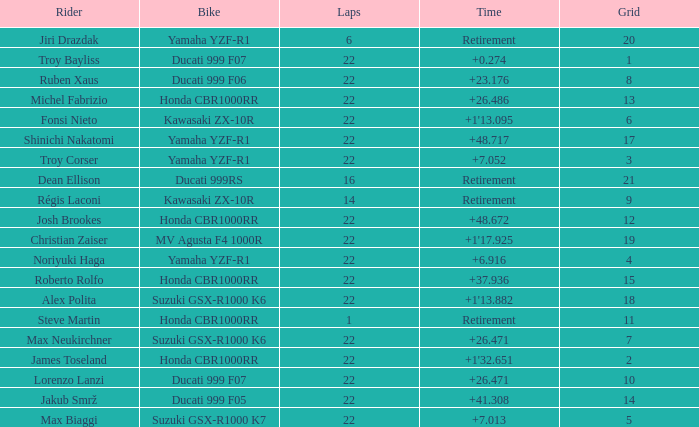Which bike did Jiri Drazdak ride when he had a grid number larger than 14 and less than 22 laps? Yamaha YZF-R1. 